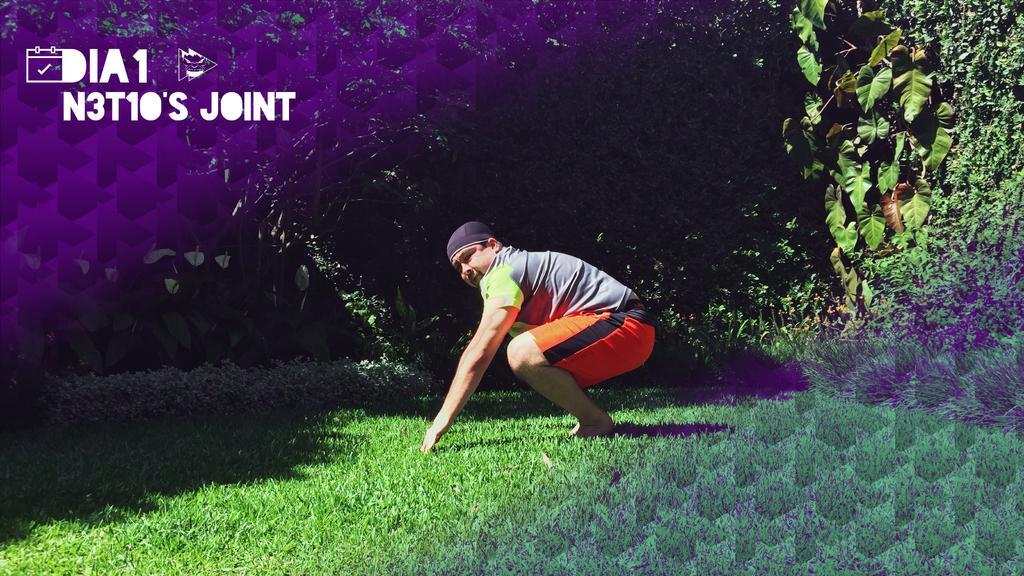Can you describe this image briefly? In this image I can see grass and on it I can see a man. I can see he is wearing t shirt, orange shorts and a black cap. In the background I can see trees and I can see shadows on ground. I can also see watermark over here. 